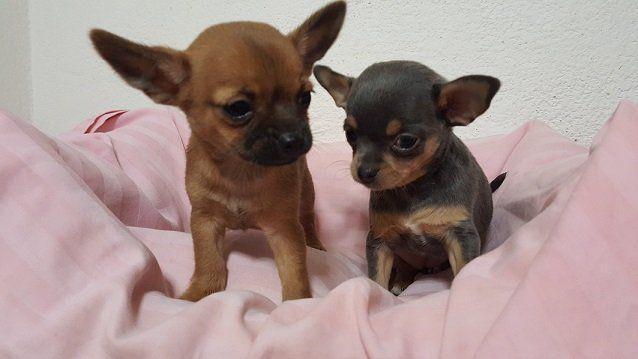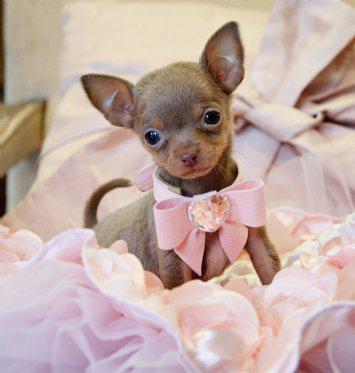The first image is the image on the left, the second image is the image on the right. Examine the images to the left and right. Is the description "At least one dog is wearing a bowtie." accurate? Answer yes or no. Yes. The first image is the image on the left, the second image is the image on the right. Evaluate the accuracy of this statement regarding the images: "There are 3 dogs in the image pair". Is it true? Answer yes or no. Yes. 